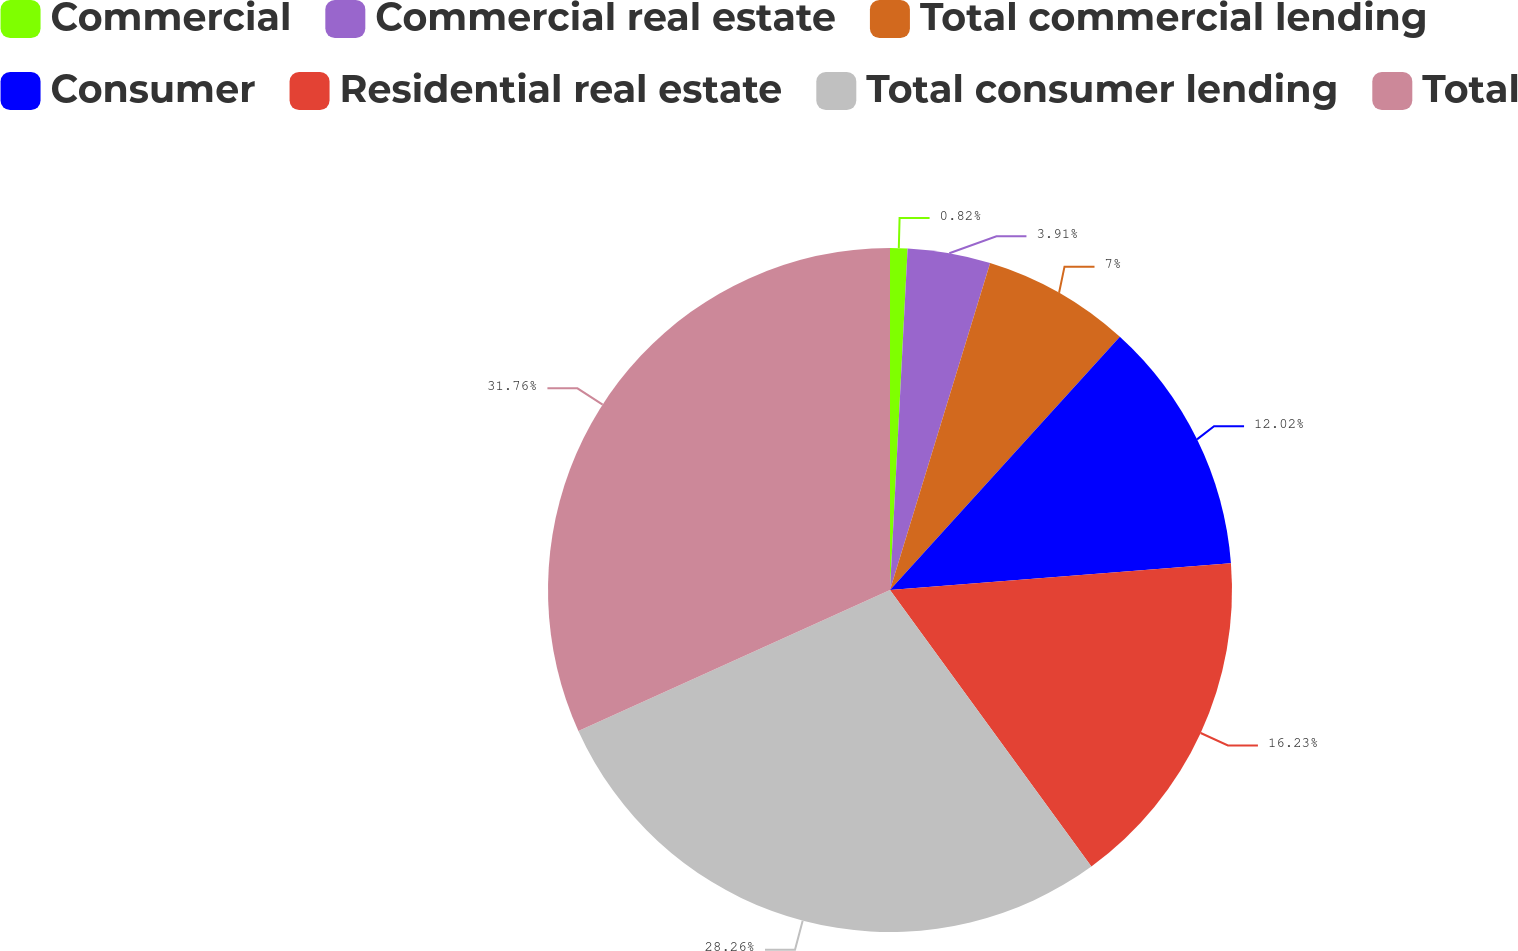Convert chart. <chart><loc_0><loc_0><loc_500><loc_500><pie_chart><fcel>Commercial<fcel>Commercial real estate<fcel>Total commercial lending<fcel>Consumer<fcel>Residential real estate<fcel>Total consumer lending<fcel>Total<nl><fcel>0.82%<fcel>3.91%<fcel>7.0%<fcel>12.02%<fcel>16.23%<fcel>28.26%<fcel>31.76%<nl></chart> 